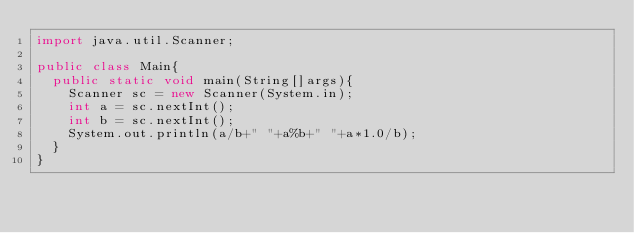Convert code to text. <code><loc_0><loc_0><loc_500><loc_500><_Java_>import java.util.Scanner;

public class Main{
	public static void main(String[]args){
		Scanner sc = new Scanner(System.in);
		int a = sc.nextInt();
		int b = sc.nextInt();
		System.out.println(a/b+" "+a%b+" "+a*1.0/b);
	}
}</code> 